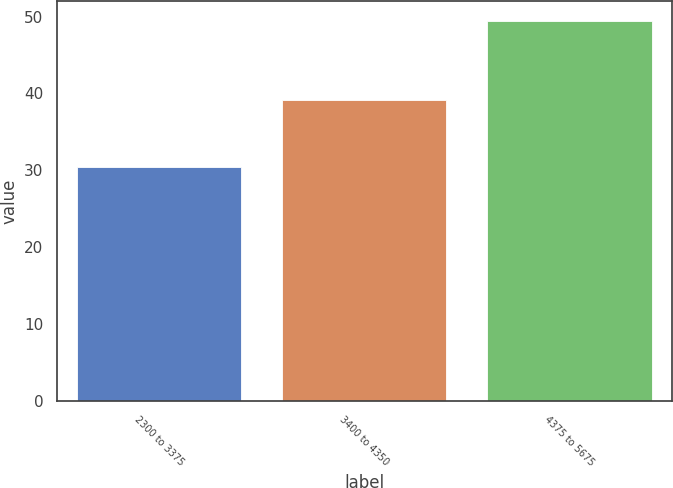Convert chart. <chart><loc_0><loc_0><loc_500><loc_500><bar_chart><fcel>2300 to 3375<fcel>3400 to 4350<fcel>4375 to 5675<nl><fcel>30.5<fcel>39.19<fcel>49.48<nl></chart> 